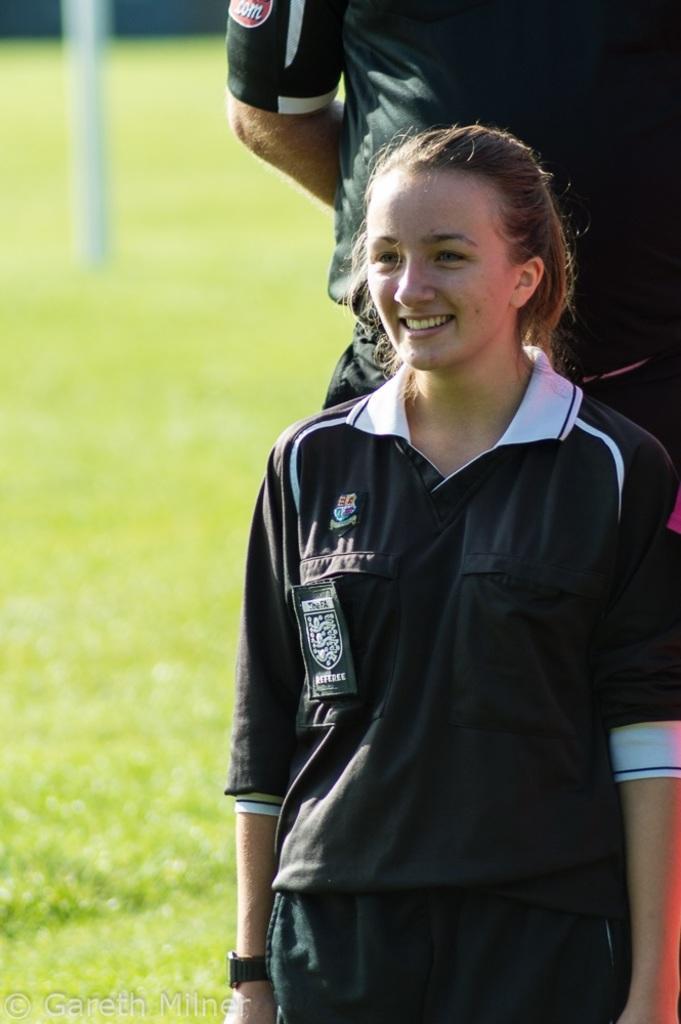In one or two sentences, can you explain what this image depicts? In this image in the foreground there is one woman who is standing and smiling, and in the background there is one person who is standing. At the bottom there is grass, and in the background there is one pole. 